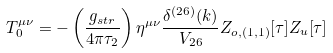Convert formula to latex. <formula><loc_0><loc_0><loc_500><loc_500>T ^ { \mu \nu } _ { 0 } = - \left ( \frac { g _ { s t r } } { 4 \pi \tau _ { 2 } } \right ) \eta ^ { \mu \nu } \frac { \delta ^ { ( 2 6 ) } ( k ) } { V _ { 2 6 } } Z _ { o , ( 1 , 1 ) } [ \tau ] Z _ { u } [ \tau ]</formula> 